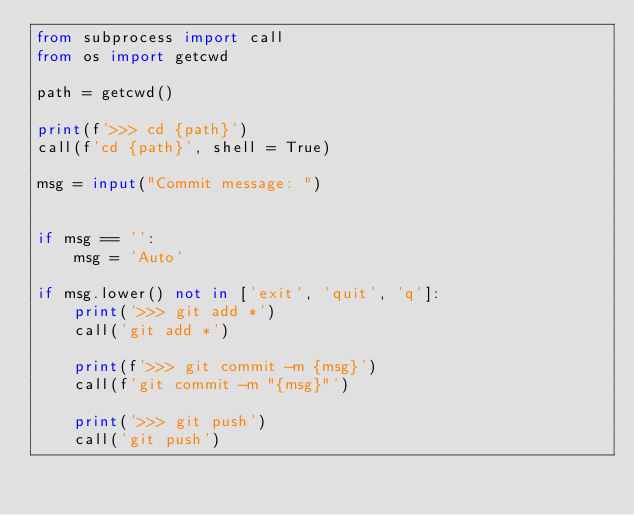Convert code to text. <code><loc_0><loc_0><loc_500><loc_500><_Python_>from subprocess import call
from os import getcwd

path = getcwd()

print(f'>>> cd {path}')
call(f'cd {path}', shell = True)

msg = input("Commit message: ")


if msg == '':
    msg = 'Auto'

if msg.lower() not in ['exit', 'quit', 'q']:
    print('>>> git add *')
    call('git add *')
    
    print(f'>>> git commit -m {msg}')
    call(f'git commit -m "{msg}"')

    print('>>> git push')
    call('git push')
</code> 